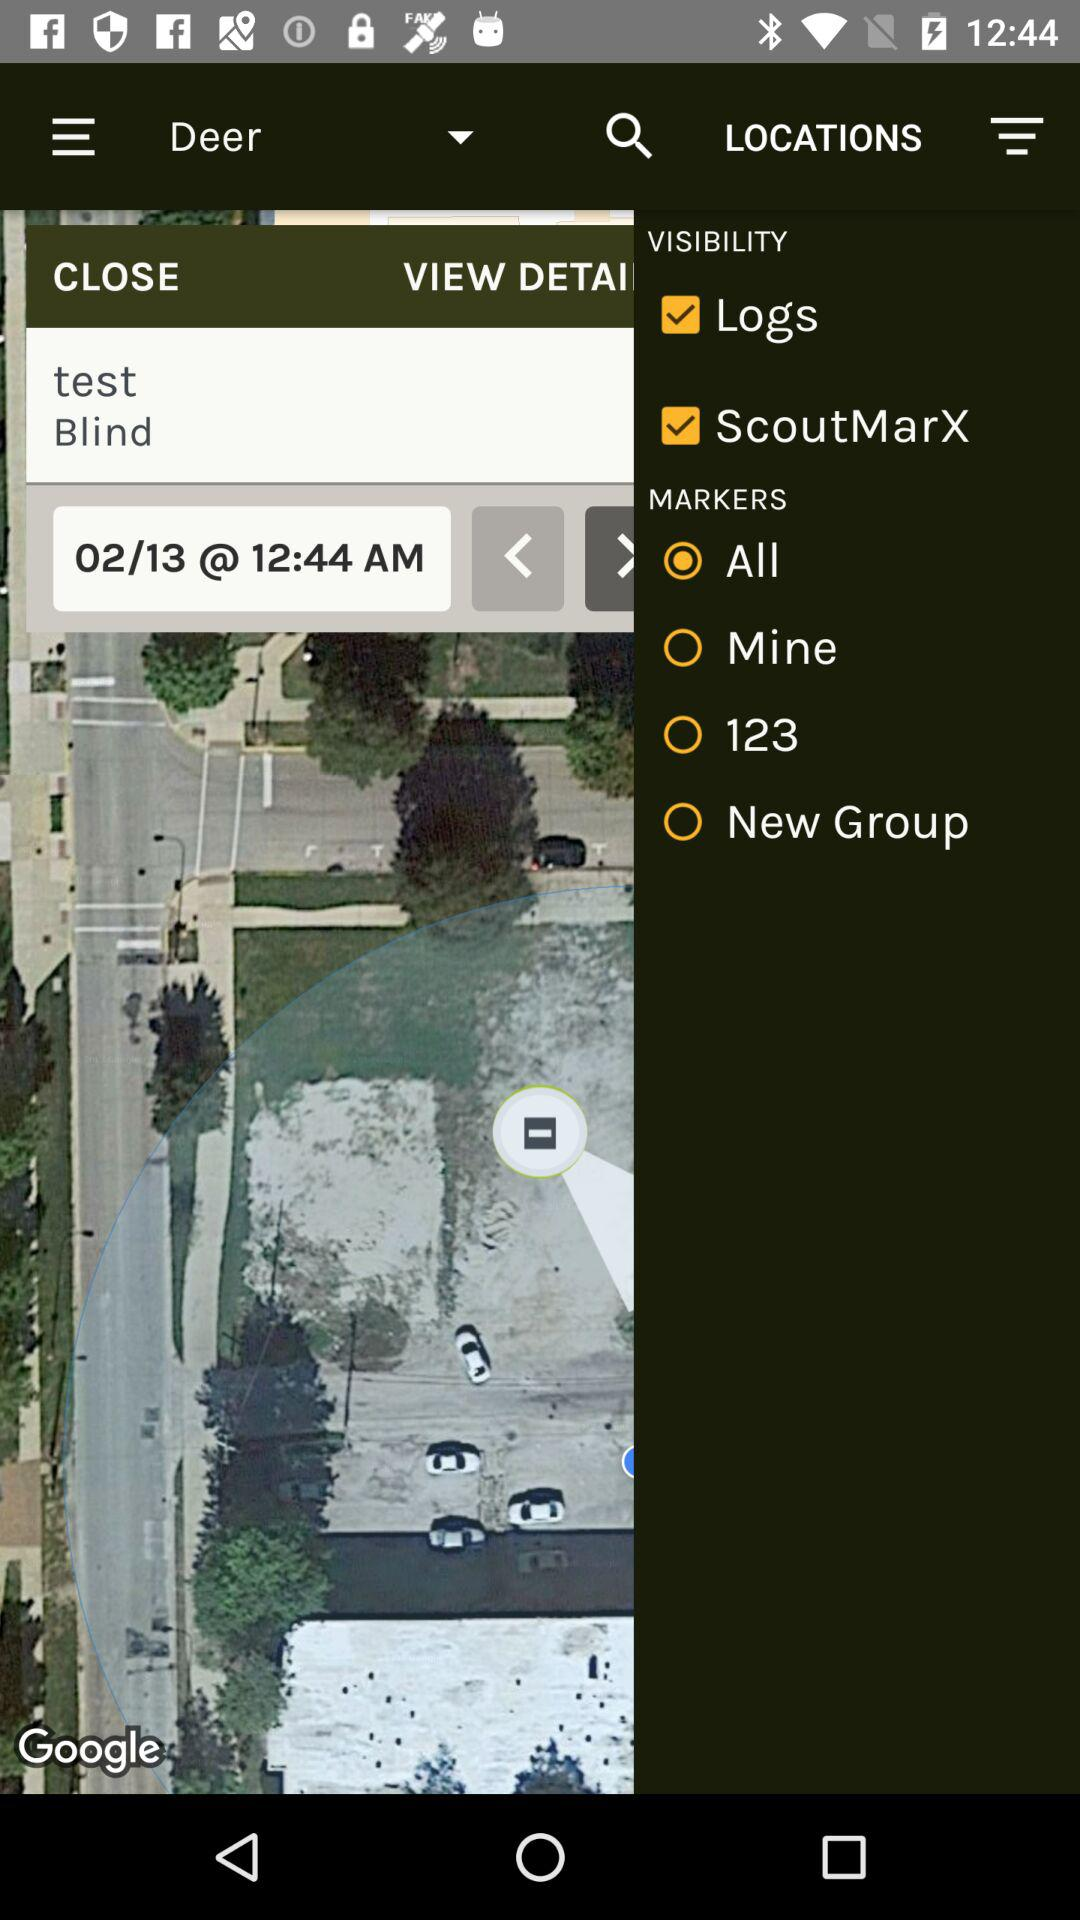What is the location?
When the provided information is insufficient, respond with <no answer>. <no answer> 